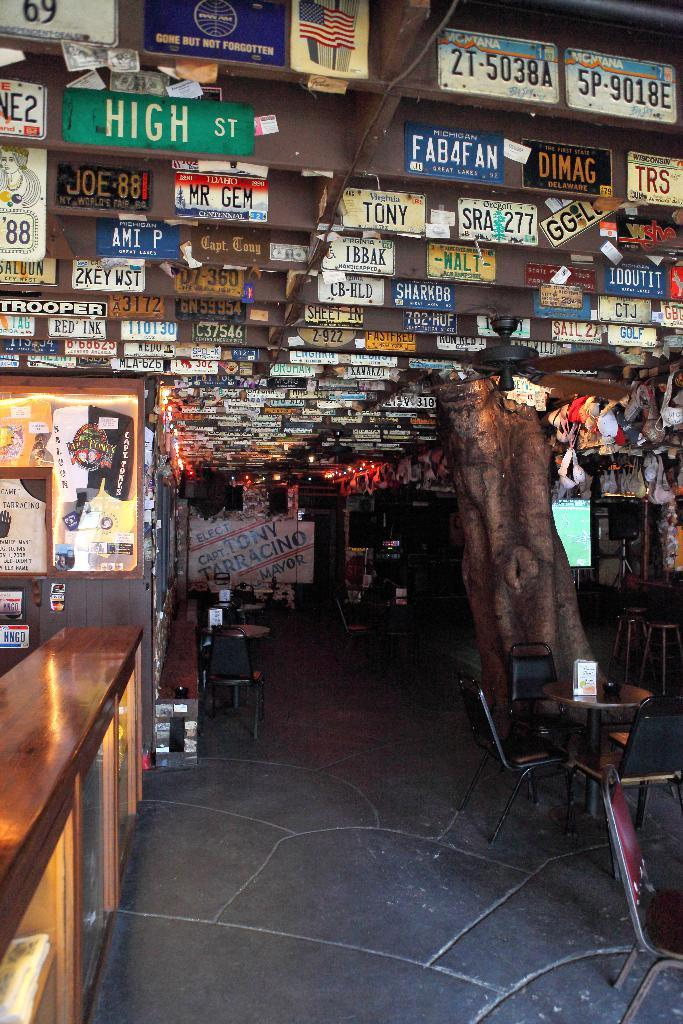<image>
Present a compact description of the photo's key features. The bar’s ceiling is covered in license plates, including ones that say High st and Tony. 